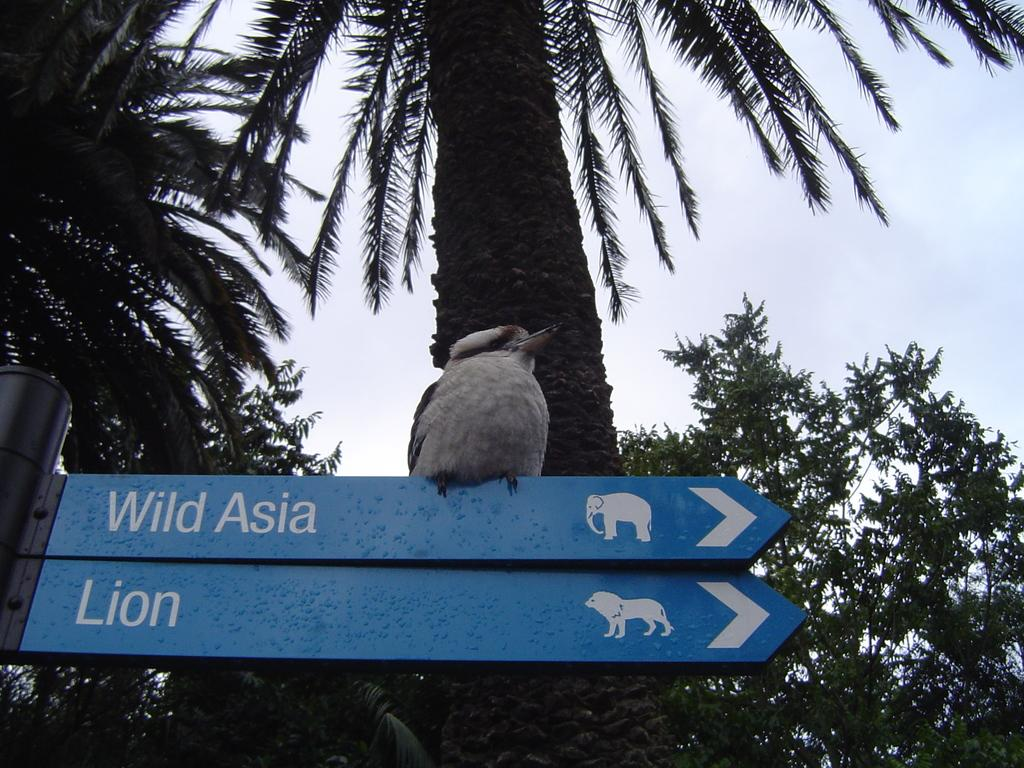What is the main object in the image? There is a sign board with a pole in the image. Is there any living creature on the sign board? Yes, there is a bird on the sign board. What can be seen in the background of the image? There are trees and the sky visible in the background of the image. What type of parcel is being delivered by the bird in the image? There is no parcel being delivered by the bird in the image; it is simply perched on the sign board. 